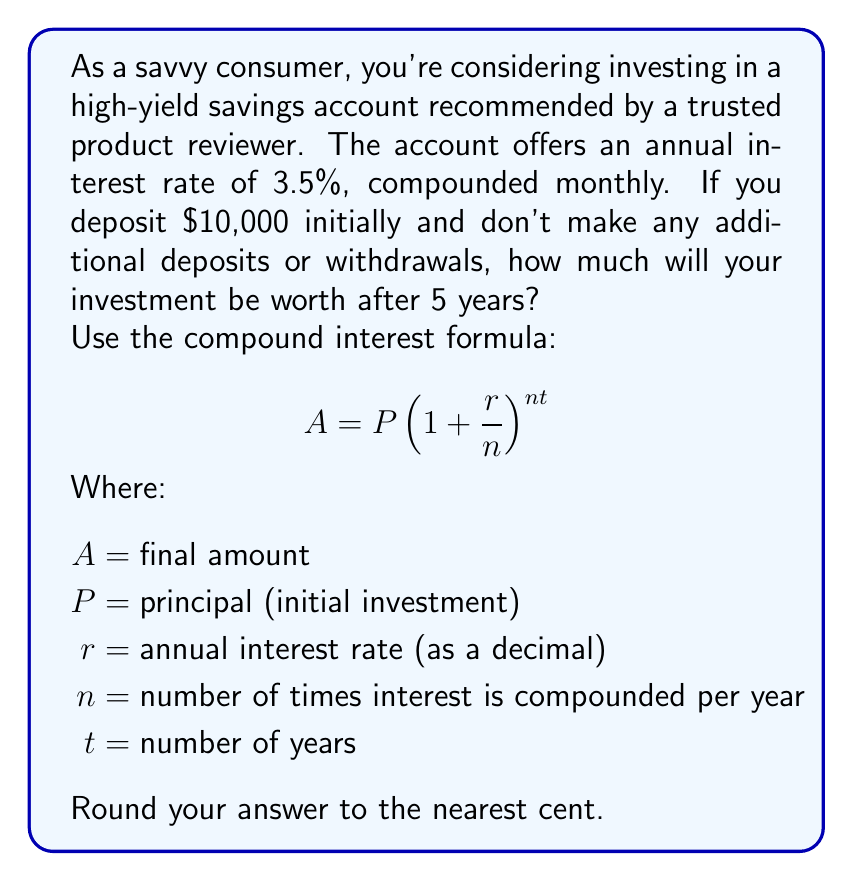Provide a solution to this math problem. Let's break this down step-by-step:

1) First, let's identify our variables:
   $P = 10000$ (initial deposit)
   $r = 0.035$ (3.5% converted to decimal)
   $n = 12$ (compounded monthly, so 12 times per year)
   $t = 5$ (5 years)

2) Now, let's plug these values into our formula:

   $$A = 10000(1 + \frac{0.035}{12})^{12 * 5}$$

3) Let's simplify the fraction inside the parentheses:
   
   $$A = 10000(1 + 0.002916667)^{60}$$

4) Now we can calculate the value inside the parentheses:
   
   $$A = 10000(1.002916667)^{60}$$

5) Using a calculator to compute this power:
   
   $$A = 10000 * 1.1910203...$$

6) Multiplying:
   
   $$A = 11910.20...$$

7) Rounding to the nearest cent:
   
   $$A = 11910.20$$

Therefore, after 5 years, your investment will be worth $11,910.20.
Answer: $11,910.20 